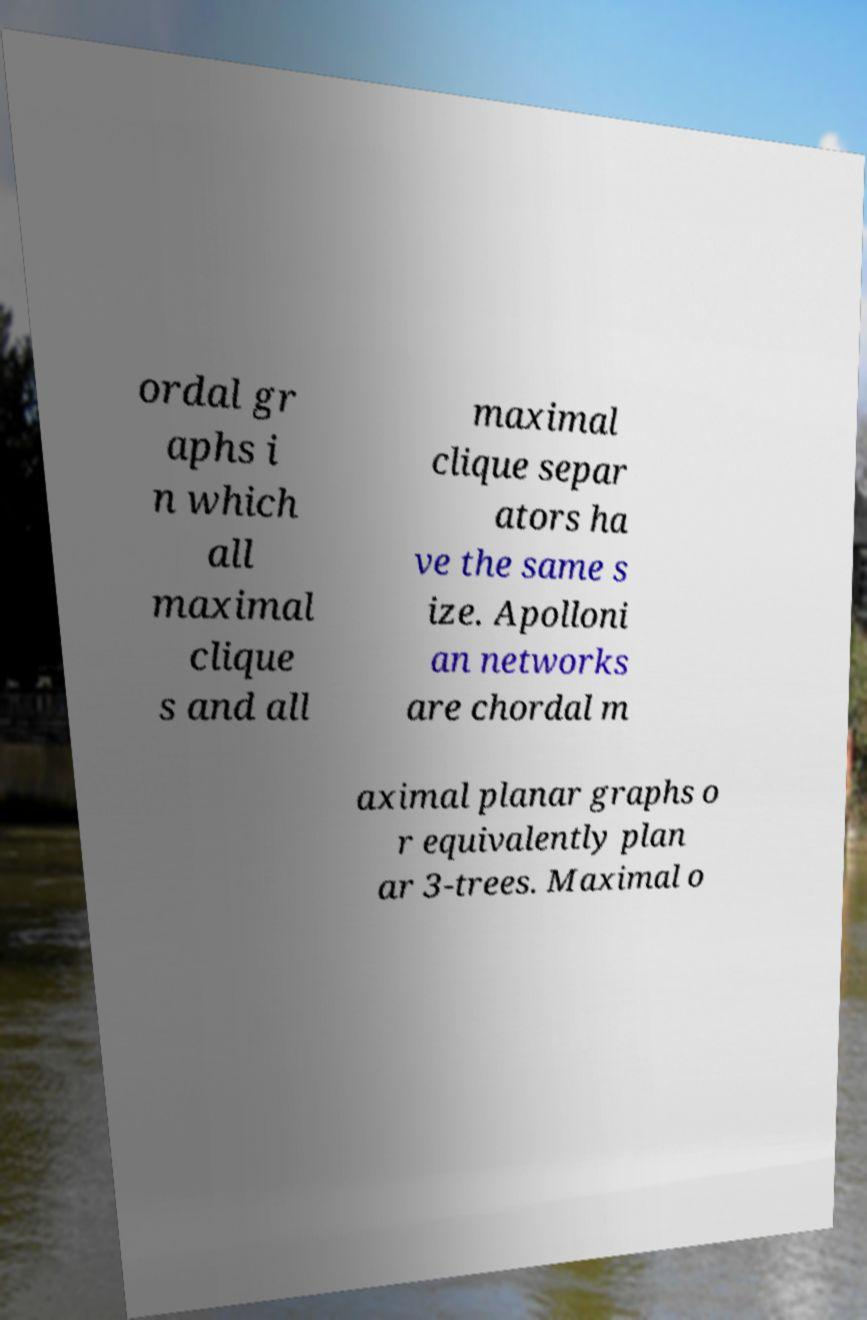Please read and relay the text visible in this image. What does it say? ordal gr aphs i n which all maximal clique s and all maximal clique separ ators ha ve the same s ize. Apolloni an networks are chordal m aximal planar graphs o r equivalently plan ar 3-trees. Maximal o 